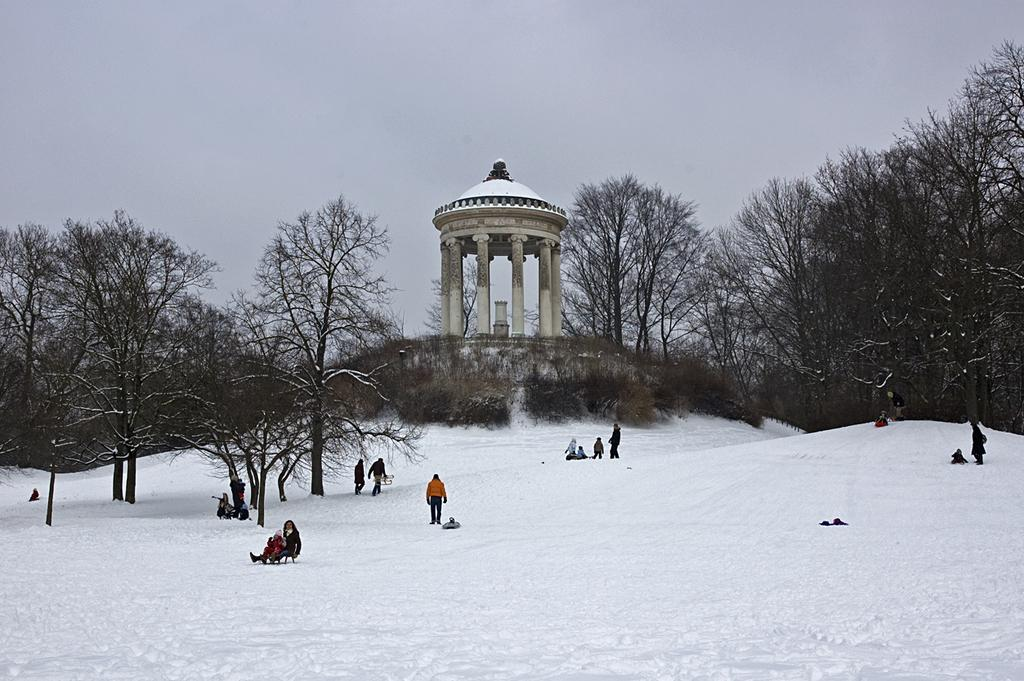What is the main subject in the center of the image? There is a group of people in the center of the image. What type of weather is depicted in the image? There is snow at the bottom of the image, indicating a winter setting. What can be seen in the background of the image? There is a building and trees in the background of the image. What is visible at the top of the image? The sky is visible at the top of the image. What type of honey can be seen dripping from the bottle in the image? There is no bottle or honey present in the image. What side of the building is visible in the image? The image only shows the building as a whole, without focusing on any specific side. 